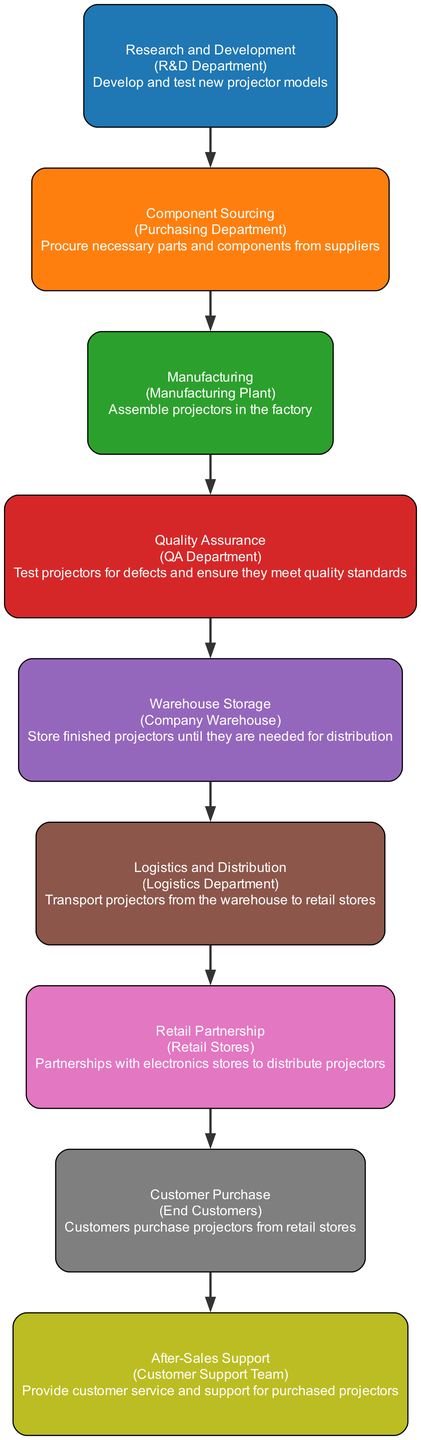What is the first step in the supply chain process? The first step in the diagram is "Research and Development," which indicates that developing and testing new projector models takes place initially in the supply chain process.
Answer: Research and Development How many main nodes are there in the diagram? By counting each distinct process represented in the diagram, we can identify that there are a total of nine main nodes, including all steps from research to after-sales support.
Answer: Nine What department is responsible for quality assurance? The node labeled "Quality Assurance" specifies that the entity responsible for this process is the "QA Department," indicating the specific department involved in testing projectors for defects.
Answer: QA Department Which node comes directly after "Warehouse Storage"? Following the "Warehouse Storage" node, the next process indicated in the flow is "Logistics and Distribution," which shows that transportation from the warehouse to retail stores is the subsequent step in the supply chain.
Answer: Logistics and Distribution How many connections are there in total among the nodes? By examining the edges connecting the nodes, we see that there are eight connections, as each node (excluding the last node) points to the next node in the sequence.
Answer: Eight What is the last step in the supply chain process? The final step represented in the diagram is "After-Sales Support," indicating that after customers purchase projectors, there is a procedure for providing customer support.
Answer: After-Sales Support Which step follows "Manufacturing"? According to the flow of the diagram, the step that follows "Manufacturing" is "Quality Assurance," which indicates that products must be tested after they are assembled.
Answer: Quality Assurance What is the primary role of the "Retail Partnership"? The "Retail Partnership" node describes its primary role as forming partnerships with electronics stores to distribute projectors, emphasizing the importance of collaboration for distribution.
Answer: Partnerships with electronics stores Which department sources the components required for manufacturing? The diagram specifies that "Component Sourcing" is conducted by the "Purchasing Department," indicating that this department is responsible for procuring necessary parts.
Answer: Purchasing Department 